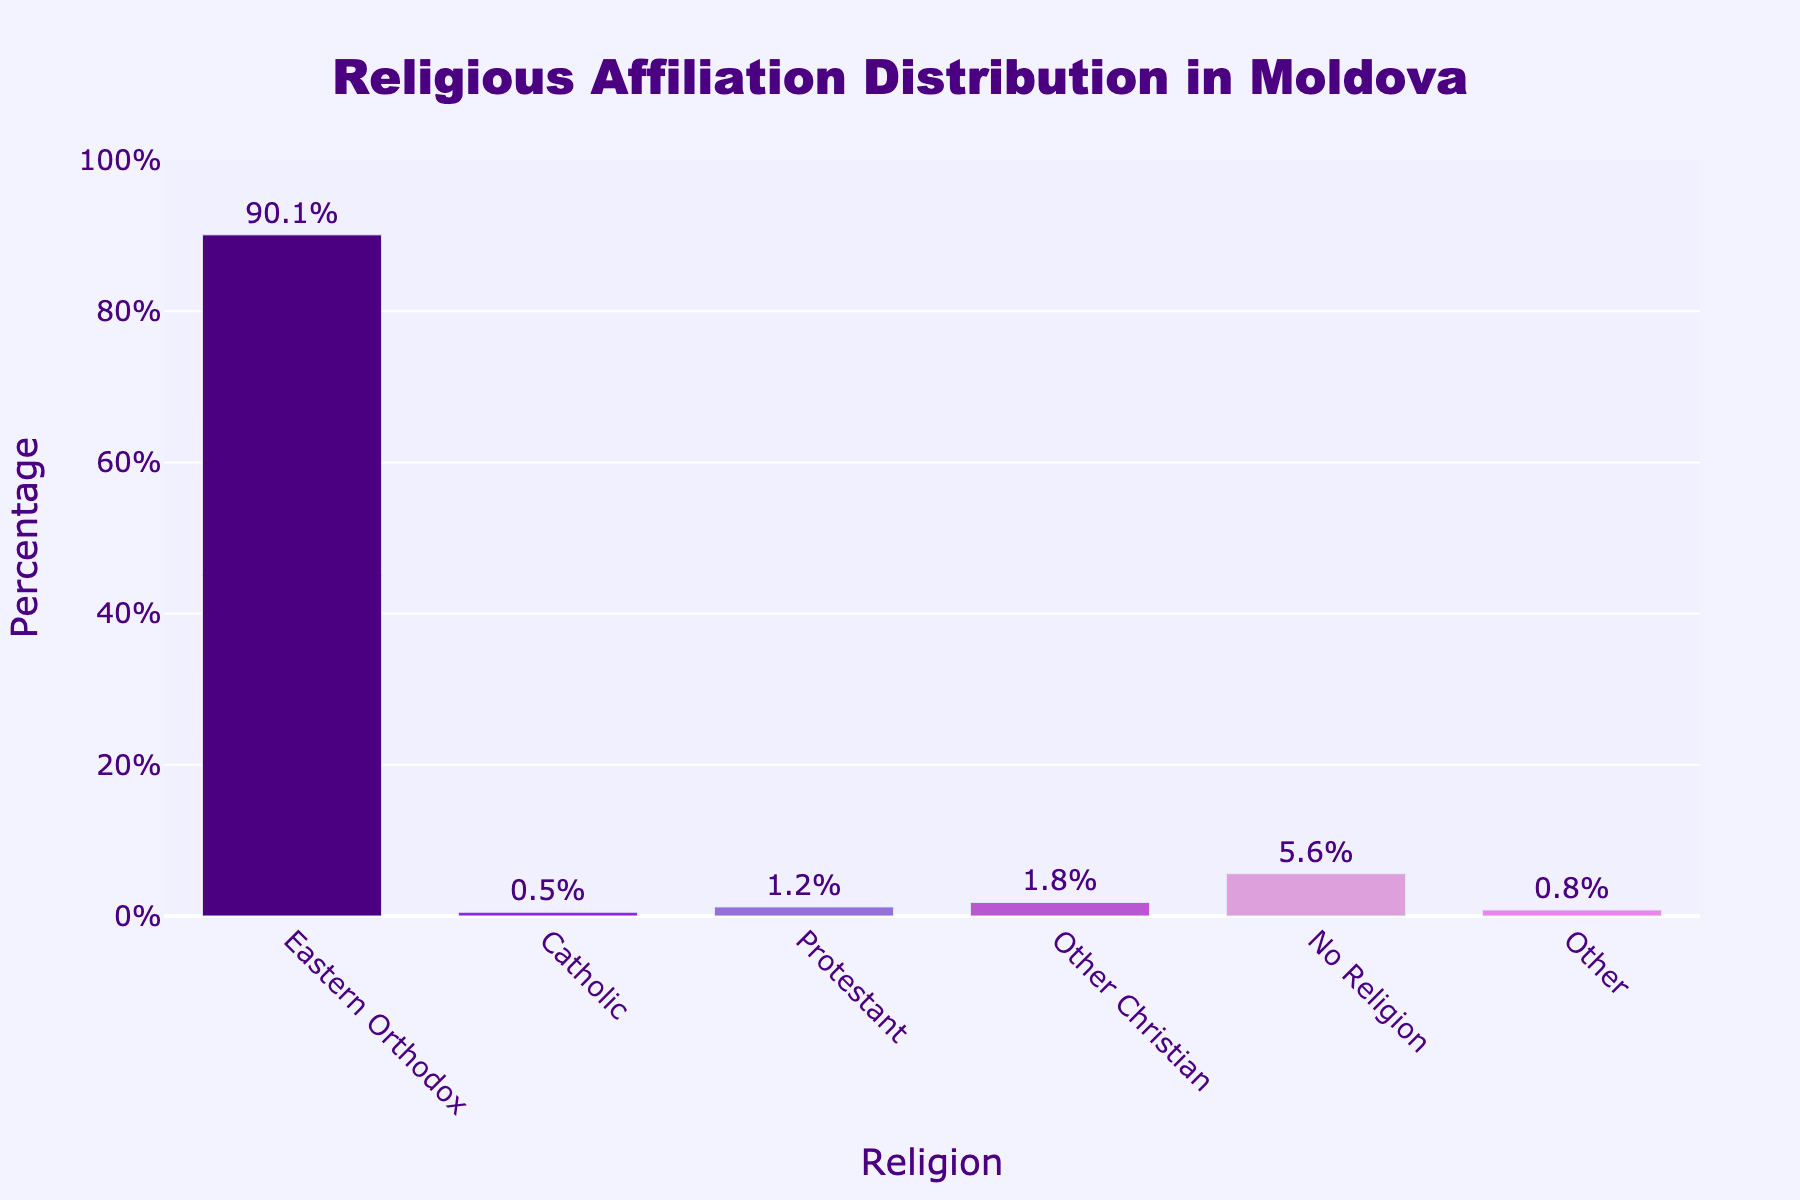Which religion has the highest percentage of affiliation in Moldova? From the bar chart, the tallest bar represents Eastern Orthodox, which has a percentage label of 90.1%. Therefore, Eastern Orthodox has the highest percentage of affiliation.
Answer: Eastern Orthodox What is the combined percentage of people affiliated with Catholic and Protestant denominations? The bar for Catholic shows 0.5% and the bar for Protestant shows 1.2%. Adding these together gives 0.5% + 1.2% = 1.7%.
Answer: 1.7% Which non-religious categories have the smallest and largest percentages? The bar for 'No Religion' is the largest among non-religious categories with 5.6%, and the bar for 'Other' is the smallest with 0.8%.
Answer: No Religion (largest), Other (smallest) What is the average percentage of people affiliated with Eastern Orthodox, Catholic, and Protestant denominations? Calculate the sum of the percentages for these religions: 90.1% + 0.5% + 1.2% = 91.8%, then divide by the number of denominations: 91.8% / 3 ≈ 30.6%.
Answer: 30.6% Compare the total percentage of people affiliated with all Christian denominations (Orthodox, Catholic, Protestant, and Other Christian) to those with No Religion. Sum the percentages of Christian denominations: 90.1% + 0.5% + 1.2% + 1.8% = 93.6%. The bar for 'No Religion' shows 5.6%. 93.6% > 5.6%.
Answer: Christian denominations (93.6%) are greater How much larger is the percentage of Eastern Orthodox affiliation compared to Protestant affiliation? Subtract the Protestant percentage from the Eastern Orthodox percentage: 90.1% - 1.2% = 88.9%.
Answer: 88.9% What percentage of people are affiliated with 'Other Christian' compared to 'Other'? 'Other Christian' bar shows 1.8% and 'Other' bar shows 0.8%. 1.8% - 0.8% = 1.0%.
Answer: 1.0% more Which color is associated with the Catholic denomination in the bar chart? The bar corresponding to Catholic is colored purple.
Answer: Purple What is the median value of all the religious affiliations listed in the chart? Order the percentages: 0.5%, 0.8%, 1.2%, 1.8%, 5.6%, 90.1%. The median value is the average of the middle two values: (1.2% + 1.8%) / 2 = 1.5%.
Answer: 1.5% If the 'No Religion' category is merged with 'Other', what would be the new total percentage for these groups? Add the percentages for 'No Religion' and 'Other': 5.6% + 0.8% = 6.4%.
Answer: 6.4% 